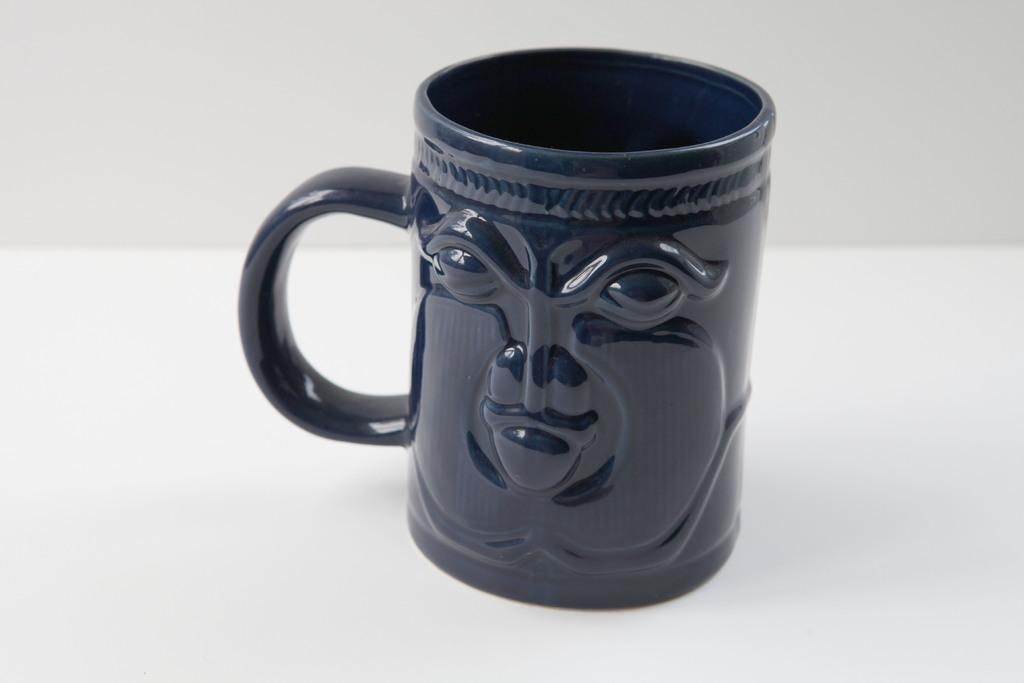How would you summarize this image in a sentence or two? There is a ceramic mug in the center of the image. 